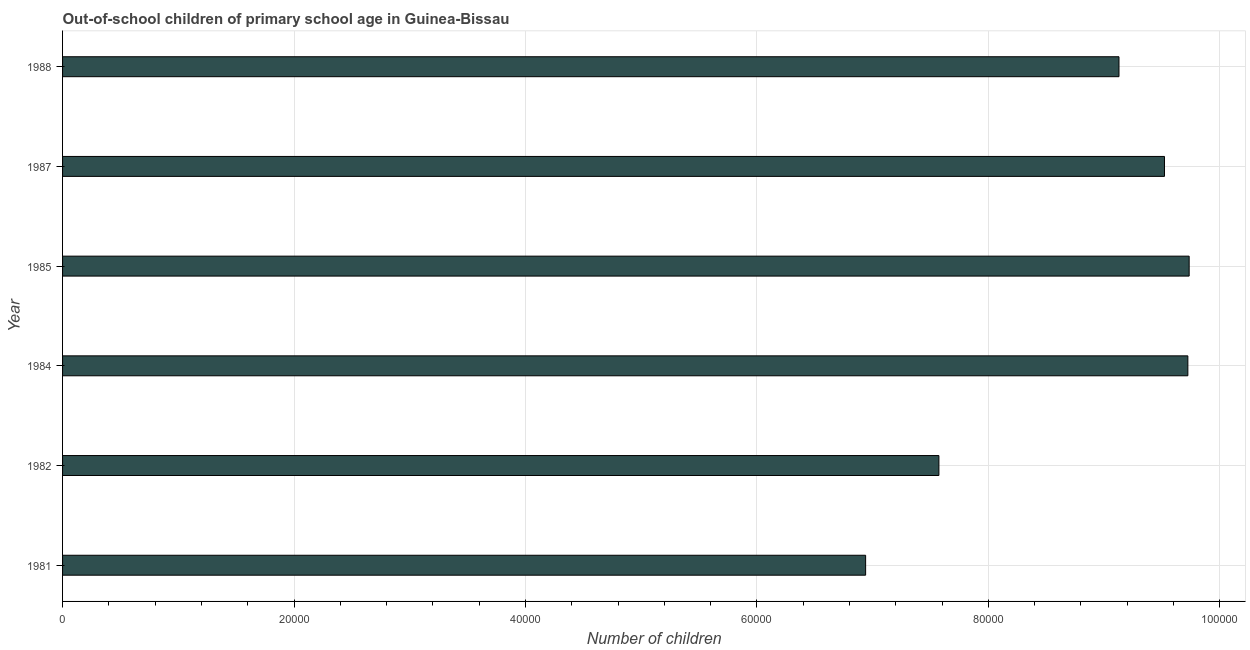What is the title of the graph?
Make the answer very short. Out-of-school children of primary school age in Guinea-Bissau. What is the label or title of the X-axis?
Your answer should be very brief. Number of children. What is the label or title of the Y-axis?
Give a very brief answer. Year. What is the number of out-of-school children in 1984?
Your response must be concise. 9.72e+04. Across all years, what is the maximum number of out-of-school children?
Give a very brief answer. 9.74e+04. Across all years, what is the minimum number of out-of-school children?
Keep it short and to the point. 6.94e+04. In which year was the number of out-of-school children minimum?
Keep it short and to the point. 1981. What is the sum of the number of out-of-school children?
Your response must be concise. 5.26e+05. What is the difference between the number of out-of-school children in 1982 and 1987?
Your answer should be compact. -1.95e+04. What is the average number of out-of-school children per year?
Make the answer very short. 8.77e+04. What is the median number of out-of-school children?
Make the answer very short. 9.33e+04. In how many years, is the number of out-of-school children greater than 80000 ?
Ensure brevity in your answer.  4. Do a majority of the years between 1987 and 1981 (inclusive) have number of out-of-school children greater than 28000 ?
Provide a succinct answer. Yes. What is the ratio of the number of out-of-school children in 1981 to that in 1988?
Give a very brief answer. 0.76. Is the difference between the number of out-of-school children in 1984 and 1988 greater than the difference between any two years?
Offer a terse response. No. What is the difference between the highest and the second highest number of out-of-school children?
Your response must be concise. 113. What is the difference between the highest and the lowest number of out-of-school children?
Your response must be concise. 2.80e+04. Are all the bars in the graph horizontal?
Provide a succinct answer. Yes. How many years are there in the graph?
Provide a short and direct response. 6. What is the difference between two consecutive major ticks on the X-axis?
Your answer should be compact. 2.00e+04. Are the values on the major ticks of X-axis written in scientific E-notation?
Give a very brief answer. No. What is the Number of children of 1981?
Offer a terse response. 6.94e+04. What is the Number of children in 1982?
Your response must be concise. 7.57e+04. What is the Number of children of 1984?
Your answer should be very brief. 9.72e+04. What is the Number of children in 1985?
Provide a short and direct response. 9.74e+04. What is the Number of children in 1987?
Offer a terse response. 9.52e+04. What is the Number of children of 1988?
Your answer should be very brief. 9.13e+04. What is the difference between the Number of children in 1981 and 1982?
Offer a terse response. -6334. What is the difference between the Number of children in 1981 and 1984?
Provide a short and direct response. -2.78e+04. What is the difference between the Number of children in 1981 and 1985?
Provide a succinct answer. -2.80e+04. What is the difference between the Number of children in 1981 and 1987?
Your answer should be compact. -2.58e+04. What is the difference between the Number of children in 1981 and 1988?
Your answer should be compact. -2.19e+04. What is the difference between the Number of children in 1982 and 1984?
Ensure brevity in your answer.  -2.15e+04. What is the difference between the Number of children in 1982 and 1985?
Offer a terse response. -2.16e+04. What is the difference between the Number of children in 1982 and 1987?
Offer a very short reply. -1.95e+04. What is the difference between the Number of children in 1982 and 1988?
Your answer should be compact. -1.56e+04. What is the difference between the Number of children in 1984 and 1985?
Give a very brief answer. -113. What is the difference between the Number of children in 1984 and 1987?
Provide a short and direct response. 2020. What is the difference between the Number of children in 1984 and 1988?
Make the answer very short. 5952. What is the difference between the Number of children in 1985 and 1987?
Provide a short and direct response. 2133. What is the difference between the Number of children in 1985 and 1988?
Your answer should be compact. 6065. What is the difference between the Number of children in 1987 and 1988?
Provide a succinct answer. 3932. What is the ratio of the Number of children in 1981 to that in 1982?
Your answer should be compact. 0.92. What is the ratio of the Number of children in 1981 to that in 1984?
Provide a short and direct response. 0.71. What is the ratio of the Number of children in 1981 to that in 1985?
Provide a succinct answer. 0.71. What is the ratio of the Number of children in 1981 to that in 1987?
Your response must be concise. 0.73. What is the ratio of the Number of children in 1981 to that in 1988?
Give a very brief answer. 0.76. What is the ratio of the Number of children in 1982 to that in 1984?
Offer a very short reply. 0.78. What is the ratio of the Number of children in 1982 to that in 1985?
Keep it short and to the point. 0.78. What is the ratio of the Number of children in 1982 to that in 1987?
Offer a very short reply. 0.8. What is the ratio of the Number of children in 1982 to that in 1988?
Offer a terse response. 0.83. What is the ratio of the Number of children in 1984 to that in 1987?
Provide a succinct answer. 1.02. What is the ratio of the Number of children in 1984 to that in 1988?
Your response must be concise. 1.06. What is the ratio of the Number of children in 1985 to that in 1987?
Your answer should be compact. 1.02. What is the ratio of the Number of children in 1985 to that in 1988?
Give a very brief answer. 1.07. What is the ratio of the Number of children in 1987 to that in 1988?
Ensure brevity in your answer.  1.04. 